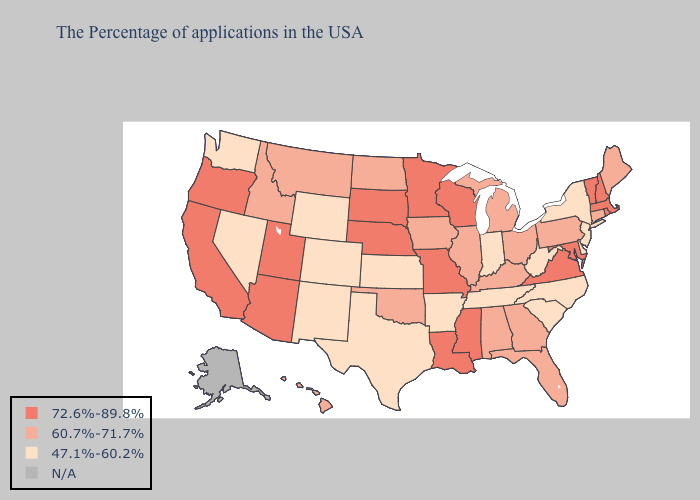What is the lowest value in states that border Arizona?
Keep it brief. 47.1%-60.2%. Does the map have missing data?
Keep it brief. Yes. What is the lowest value in the MidWest?
Keep it brief. 47.1%-60.2%. What is the lowest value in the Northeast?
Answer briefly. 47.1%-60.2%. Does the map have missing data?
Give a very brief answer. Yes. What is the value of Washington?
Be succinct. 47.1%-60.2%. Name the states that have a value in the range 60.7%-71.7%?
Answer briefly. Maine, Connecticut, Pennsylvania, Ohio, Florida, Georgia, Michigan, Kentucky, Alabama, Illinois, Iowa, Oklahoma, North Dakota, Montana, Idaho, Hawaii. How many symbols are there in the legend?
Quick response, please. 4. What is the highest value in the South ?
Keep it brief. 72.6%-89.8%. What is the highest value in the West ?
Give a very brief answer. 72.6%-89.8%. Does Massachusetts have the highest value in the Northeast?
Give a very brief answer. Yes. What is the value of California?
Answer briefly. 72.6%-89.8%. What is the value of West Virginia?
Answer briefly. 47.1%-60.2%. 